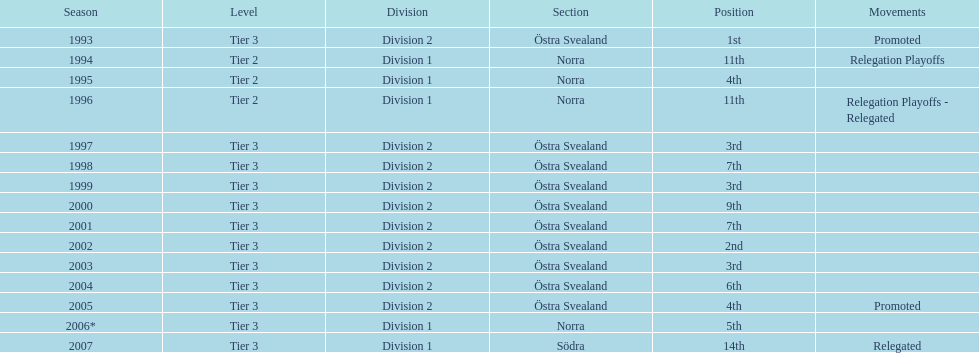How many times did they end up higher than 5th place in division 2 tier 3? 6. 